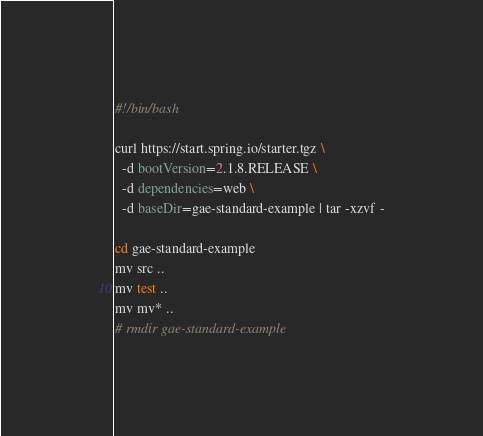Convert code to text. <code><loc_0><loc_0><loc_500><loc_500><_Bash_>#!/bin/bash

curl https://start.spring.io/starter.tgz \
  -d bootVersion=2.1.8.RELEASE \
  -d dependencies=web \
  -d baseDir=gae-standard-example | tar -xzvf -

cd gae-standard-example
mv src ..
mv test ..
mv mv* ..
# rmdir gae-standard-example</code> 